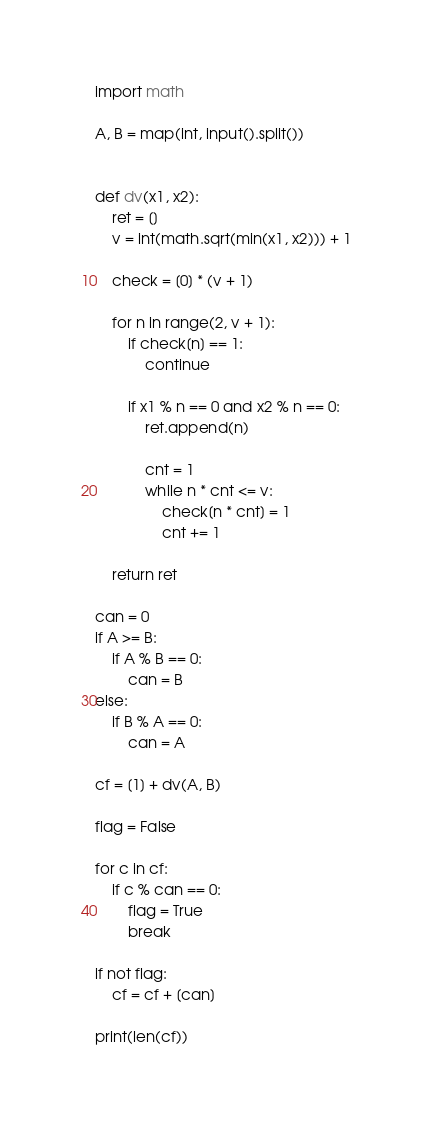<code> <loc_0><loc_0><loc_500><loc_500><_Python_>import math

A, B = map(int, input().split())


def dv(x1, x2):
    ret = []
    v = int(math.sqrt(min(x1, x2))) + 1

    check = [0] * (v + 1)

    for n in range(2, v + 1):
        if check[n] == 1:
            continue

        if x1 % n == 0 and x2 % n == 0:
            ret.append(n)

            cnt = 1
            while n * cnt <= v:
                check[n * cnt] = 1
                cnt += 1

    return ret

can = 0
if A >= B:
    if A % B == 0:
        can = B
else:
    if B % A == 0:
        can = A

cf = [1] + dv(A, B)

flag = False

for c in cf:
    if c % can == 0:
        flag = True
        break
        
if not flag:
    cf = cf + [can]

print(len(cf))</code> 